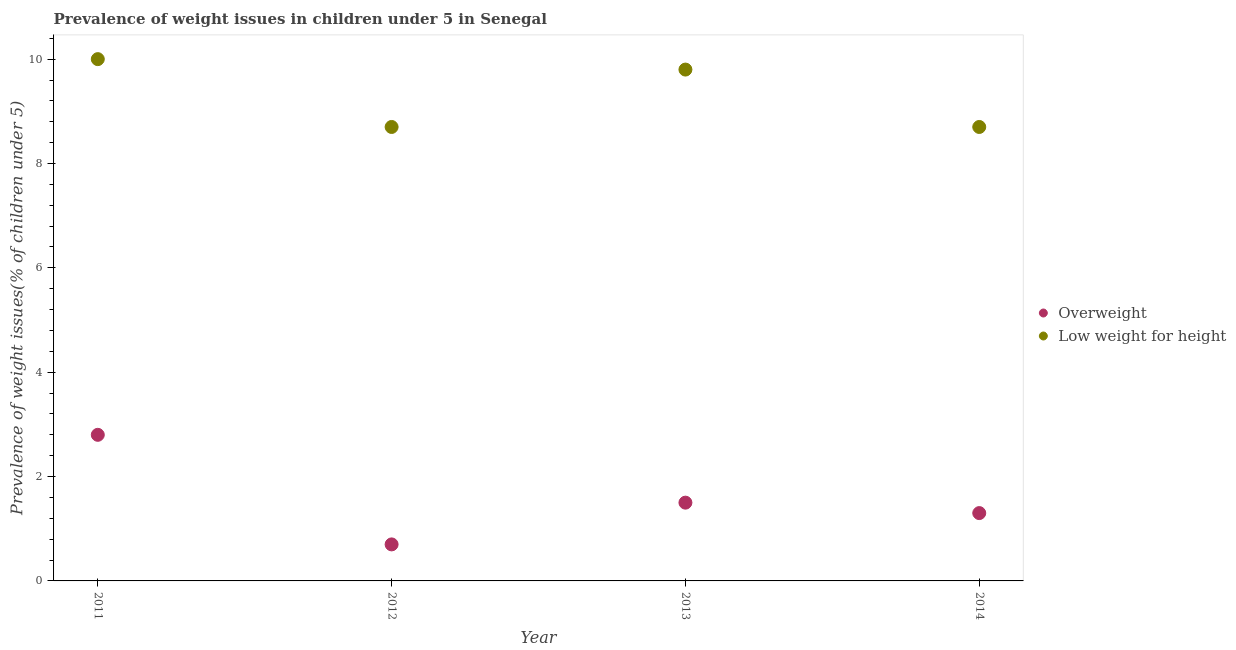Is the number of dotlines equal to the number of legend labels?
Provide a succinct answer. Yes. What is the percentage of overweight children in 2013?
Offer a very short reply. 1.5. Across all years, what is the maximum percentage of overweight children?
Your answer should be very brief. 2.8. Across all years, what is the minimum percentage of overweight children?
Your answer should be very brief. 0.7. What is the total percentage of overweight children in the graph?
Offer a very short reply. 6.3. What is the difference between the percentage of underweight children in 2013 and that in 2014?
Your answer should be very brief. 1.1. What is the difference between the percentage of overweight children in 2013 and the percentage of underweight children in 2012?
Your response must be concise. -7.2. What is the average percentage of underweight children per year?
Provide a short and direct response. 9.3. In the year 2014, what is the difference between the percentage of overweight children and percentage of underweight children?
Ensure brevity in your answer.  -7.4. In how many years, is the percentage of underweight children greater than 0.8 %?
Give a very brief answer. 4. What is the ratio of the percentage of overweight children in 2011 to that in 2014?
Give a very brief answer. 2.15. What is the difference between the highest and the second highest percentage of overweight children?
Your response must be concise. 1.3. What is the difference between the highest and the lowest percentage of overweight children?
Provide a short and direct response. 2.1. Does the percentage of underweight children monotonically increase over the years?
Provide a succinct answer. No. How many dotlines are there?
Your answer should be very brief. 2. What is the difference between two consecutive major ticks on the Y-axis?
Give a very brief answer. 2. How are the legend labels stacked?
Ensure brevity in your answer.  Vertical. What is the title of the graph?
Ensure brevity in your answer.  Prevalence of weight issues in children under 5 in Senegal. Does "Secondary" appear as one of the legend labels in the graph?
Make the answer very short. No. What is the label or title of the X-axis?
Offer a terse response. Year. What is the label or title of the Y-axis?
Ensure brevity in your answer.  Prevalence of weight issues(% of children under 5). What is the Prevalence of weight issues(% of children under 5) of Overweight in 2011?
Offer a very short reply. 2.8. What is the Prevalence of weight issues(% of children under 5) in Overweight in 2012?
Your answer should be compact. 0.7. What is the Prevalence of weight issues(% of children under 5) in Low weight for height in 2012?
Your response must be concise. 8.7. What is the Prevalence of weight issues(% of children under 5) in Low weight for height in 2013?
Provide a succinct answer. 9.8. What is the Prevalence of weight issues(% of children under 5) of Overweight in 2014?
Offer a very short reply. 1.3. What is the Prevalence of weight issues(% of children under 5) of Low weight for height in 2014?
Offer a very short reply. 8.7. Across all years, what is the maximum Prevalence of weight issues(% of children under 5) of Overweight?
Your answer should be compact. 2.8. Across all years, what is the maximum Prevalence of weight issues(% of children under 5) in Low weight for height?
Your answer should be very brief. 10. Across all years, what is the minimum Prevalence of weight issues(% of children under 5) in Overweight?
Offer a terse response. 0.7. Across all years, what is the minimum Prevalence of weight issues(% of children under 5) in Low weight for height?
Make the answer very short. 8.7. What is the total Prevalence of weight issues(% of children under 5) of Overweight in the graph?
Provide a succinct answer. 6.3. What is the total Prevalence of weight issues(% of children under 5) of Low weight for height in the graph?
Keep it short and to the point. 37.2. What is the difference between the Prevalence of weight issues(% of children under 5) of Overweight in 2011 and that in 2012?
Your response must be concise. 2.1. What is the difference between the Prevalence of weight issues(% of children under 5) in Overweight in 2011 and that in 2013?
Provide a succinct answer. 1.3. What is the difference between the Prevalence of weight issues(% of children under 5) in Overweight in 2012 and that in 2013?
Give a very brief answer. -0.8. What is the difference between the Prevalence of weight issues(% of children under 5) of Low weight for height in 2012 and that in 2013?
Make the answer very short. -1.1. What is the difference between the Prevalence of weight issues(% of children under 5) of Low weight for height in 2012 and that in 2014?
Give a very brief answer. 0. What is the difference between the Prevalence of weight issues(% of children under 5) of Overweight in 2013 and that in 2014?
Give a very brief answer. 0.2. What is the difference between the Prevalence of weight issues(% of children under 5) in Overweight in 2011 and the Prevalence of weight issues(% of children under 5) in Low weight for height in 2014?
Your answer should be compact. -5.9. What is the difference between the Prevalence of weight issues(% of children under 5) of Overweight in 2012 and the Prevalence of weight issues(% of children under 5) of Low weight for height in 2014?
Give a very brief answer. -8. What is the difference between the Prevalence of weight issues(% of children under 5) in Overweight in 2013 and the Prevalence of weight issues(% of children under 5) in Low weight for height in 2014?
Provide a short and direct response. -7.2. What is the average Prevalence of weight issues(% of children under 5) of Overweight per year?
Your answer should be very brief. 1.57. In the year 2012, what is the difference between the Prevalence of weight issues(% of children under 5) of Overweight and Prevalence of weight issues(% of children under 5) of Low weight for height?
Give a very brief answer. -8. In the year 2013, what is the difference between the Prevalence of weight issues(% of children under 5) of Overweight and Prevalence of weight issues(% of children under 5) of Low weight for height?
Give a very brief answer. -8.3. What is the ratio of the Prevalence of weight issues(% of children under 5) of Low weight for height in 2011 to that in 2012?
Give a very brief answer. 1.15. What is the ratio of the Prevalence of weight issues(% of children under 5) of Overweight in 2011 to that in 2013?
Provide a short and direct response. 1.87. What is the ratio of the Prevalence of weight issues(% of children under 5) in Low weight for height in 2011 to that in 2013?
Keep it short and to the point. 1.02. What is the ratio of the Prevalence of weight issues(% of children under 5) in Overweight in 2011 to that in 2014?
Make the answer very short. 2.15. What is the ratio of the Prevalence of weight issues(% of children under 5) in Low weight for height in 2011 to that in 2014?
Your answer should be compact. 1.15. What is the ratio of the Prevalence of weight issues(% of children under 5) in Overweight in 2012 to that in 2013?
Your answer should be very brief. 0.47. What is the ratio of the Prevalence of weight issues(% of children under 5) in Low weight for height in 2012 to that in 2013?
Make the answer very short. 0.89. What is the ratio of the Prevalence of weight issues(% of children under 5) in Overweight in 2012 to that in 2014?
Offer a terse response. 0.54. What is the ratio of the Prevalence of weight issues(% of children under 5) of Low weight for height in 2012 to that in 2014?
Offer a very short reply. 1. What is the ratio of the Prevalence of weight issues(% of children under 5) of Overweight in 2013 to that in 2014?
Your response must be concise. 1.15. What is the ratio of the Prevalence of weight issues(% of children under 5) of Low weight for height in 2013 to that in 2014?
Ensure brevity in your answer.  1.13. What is the difference between the highest and the second highest Prevalence of weight issues(% of children under 5) in Overweight?
Your answer should be compact. 1.3. What is the difference between the highest and the second highest Prevalence of weight issues(% of children under 5) of Low weight for height?
Ensure brevity in your answer.  0.2. What is the difference between the highest and the lowest Prevalence of weight issues(% of children under 5) of Overweight?
Your answer should be compact. 2.1. What is the difference between the highest and the lowest Prevalence of weight issues(% of children under 5) of Low weight for height?
Your response must be concise. 1.3. 